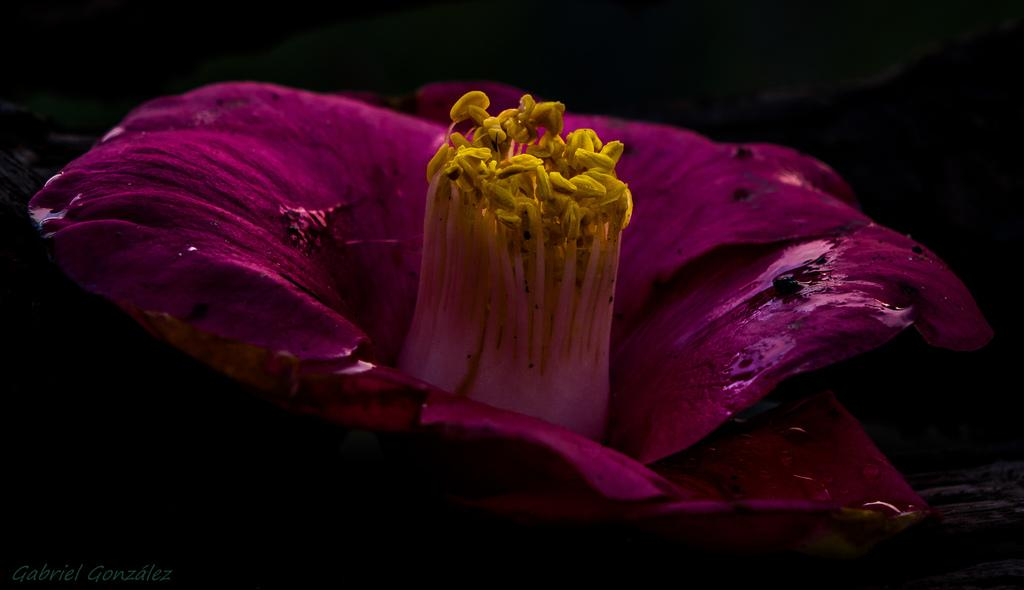What is the main subject of the image? The main subject of the image is a flower. Can you describe any specific features of the flower? Yes, the flower has an anther. How many horses can be seen grazing near the flower in the image? There are no horses present in the image; it features a flower with an anther. What type of fork is used to water the flower in the image? There is no fork present in the image, and the flower does not require watering as it is a still image. 